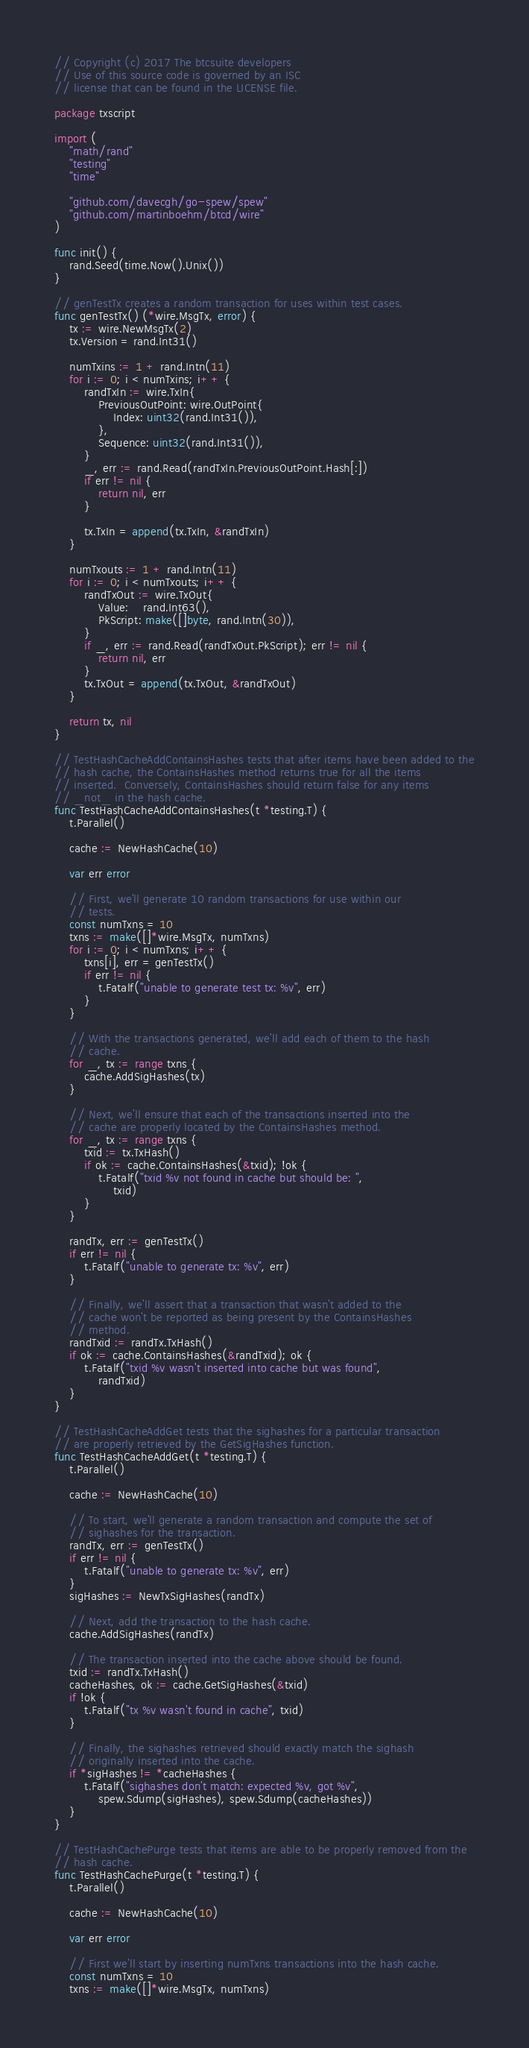Convert code to text. <code><loc_0><loc_0><loc_500><loc_500><_Go_>// Copyright (c) 2017 The btcsuite developers
// Use of this source code is governed by an ISC
// license that can be found in the LICENSE file.

package txscript

import (
	"math/rand"
	"testing"
	"time"

	"github.com/davecgh/go-spew/spew"
	"github.com/martinboehm/btcd/wire"
)

func init() {
	rand.Seed(time.Now().Unix())
}

// genTestTx creates a random transaction for uses within test cases.
func genTestTx() (*wire.MsgTx, error) {
	tx := wire.NewMsgTx(2)
	tx.Version = rand.Int31()

	numTxins := 1 + rand.Intn(11)
	for i := 0; i < numTxins; i++ {
		randTxIn := wire.TxIn{
			PreviousOutPoint: wire.OutPoint{
				Index: uint32(rand.Int31()),
			},
			Sequence: uint32(rand.Int31()),
		}
		_, err := rand.Read(randTxIn.PreviousOutPoint.Hash[:])
		if err != nil {
			return nil, err
		}

		tx.TxIn = append(tx.TxIn, &randTxIn)
	}

	numTxouts := 1 + rand.Intn(11)
	for i := 0; i < numTxouts; i++ {
		randTxOut := wire.TxOut{
			Value:    rand.Int63(),
			PkScript: make([]byte, rand.Intn(30)),
		}
		if _, err := rand.Read(randTxOut.PkScript); err != nil {
			return nil, err
		}
		tx.TxOut = append(tx.TxOut, &randTxOut)
	}

	return tx, nil
}

// TestHashCacheAddContainsHashes tests that after items have been added to the
// hash cache, the ContainsHashes method returns true for all the items
// inserted.  Conversely, ContainsHashes should return false for any items
// _not_ in the hash cache.
func TestHashCacheAddContainsHashes(t *testing.T) {
	t.Parallel()

	cache := NewHashCache(10)

	var err error

	// First, we'll generate 10 random transactions for use within our
	// tests.
	const numTxns = 10
	txns := make([]*wire.MsgTx, numTxns)
	for i := 0; i < numTxns; i++ {
		txns[i], err = genTestTx()
		if err != nil {
			t.Fatalf("unable to generate test tx: %v", err)
		}
	}

	// With the transactions generated, we'll add each of them to the hash
	// cache.
	for _, tx := range txns {
		cache.AddSigHashes(tx)
	}

	// Next, we'll ensure that each of the transactions inserted into the
	// cache are properly located by the ContainsHashes method.
	for _, tx := range txns {
		txid := tx.TxHash()
		if ok := cache.ContainsHashes(&txid); !ok {
			t.Fatalf("txid %v not found in cache but should be: ",
				txid)
		}
	}

	randTx, err := genTestTx()
	if err != nil {
		t.Fatalf("unable to generate tx: %v", err)
	}

	// Finally, we'll assert that a transaction that wasn't added to the
	// cache won't be reported as being present by the ContainsHashes
	// method.
	randTxid := randTx.TxHash()
	if ok := cache.ContainsHashes(&randTxid); ok {
		t.Fatalf("txid %v wasn't inserted into cache but was found",
			randTxid)
	}
}

// TestHashCacheAddGet tests that the sighashes for a particular transaction
// are properly retrieved by the GetSigHashes function.
func TestHashCacheAddGet(t *testing.T) {
	t.Parallel()

	cache := NewHashCache(10)

	// To start, we'll generate a random transaction and compute the set of
	// sighashes for the transaction.
	randTx, err := genTestTx()
	if err != nil {
		t.Fatalf("unable to generate tx: %v", err)
	}
	sigHashes := NewTxSigHashes(randTx)

	// Next, add the transaction to the hash cache.
	cache.AddSigHashes(randTx)

	// The transaction inserted into the cache above should be found.
	txid := randTx.TxHash()
	cacheHashes, ok := cache.GetSigHashes(&txid)
	if !ok {
		t.Fatalf("tx %v wasn't found in cache", txid)
	}

	// Finally, the sighashes retrieved should exactly match the sighash
	// originally inserted into the cache.
	if *sigHashes != *cacheHashes {
		t.Fatalf("sighashes don't match: expected %v, got %v",
			spew.Sdump(sigHashes), spew.Sdump(cacheHashes))
	}
}

// TestHashCachePurge tests that items are able to be properly removed from the
// hash cache.
func TestHashCachePurge(t *testing.T) {
	t.Parallel()

	cache := NewHashCache(10)

	var err error

	// First we'll start by inserting numTxns transactions into the hash cache.
	const numTxns = 10
	txns := make([]*wire.MsgTx, numTxns)</code> 